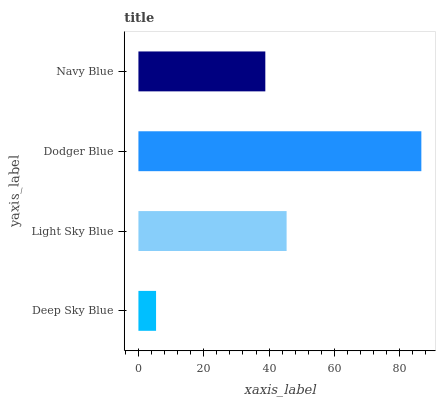Is Deep Sky Blue the minimum?
Answer yes or no. Yes. Is Dodger Blue the maximum?
Answer yes or no. Yes. Is Light Sky Blue the minimum?
Answer yes or no. No. Is Light Sky Blue the maximum?
Answer yes or no. No. Is Light Sky Blue greater than Deep Sky Blue?
Answer yes or no. Yes. Is Deep Sky Blue less than Light Sky Blue?
Answer yes or no. Yes. Is Deep Sky Blue greater than Light Sky Blue?
Answer yes or no. No. Is Light Sky Blue less than Deep Sky Blue?
Answer yes or no. No. Is Light Sky Blue the high median?
Answer yes or no. Yes. Is Navy Blue the low median?
Answer yes or no. Yes. Is Dodger Blue the high median?
Answer yes or no. No. Is Dodger Blue the low median?
Answer yes or no. No. 